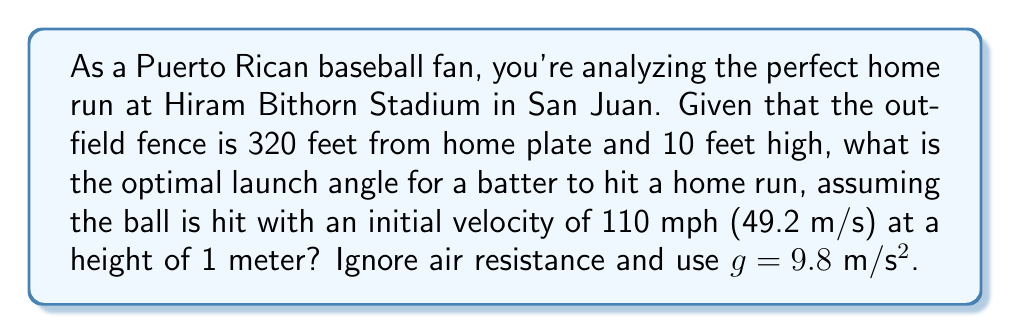Show me your answer to this math problem. Let's approach this step-by-step using projectile motion equations:

1) First, convert all units to meters:
   320 feet ≈ 97.54 m (horizontal distance)
   10 feet ≈ 3.05 m (fence height)
   110 mph = 49.2 m/s (initial velocity)

2) We need to find the angle θ that allows the ball to just clear the fence. The projectile motion equations we'll use are:

   $$x = v_0 \cos(\theta) t$$
   $$y = v_0 \sin(\theta) t - \frac{1}{2}gt^2 + y_0$$

   Where $x$ is horizontal distance, $y$ is vertical distance, $v_0$ is initial velocity, $t$ is time, $g$ is acceleration due to gravity, and $y_0$ is initial height.

3) At the fence, $x = 97.54$ m and $y = 3.05$ m. Solve for $t$ in the first equation:

   $$t = \frac{97.54}{49.2 \cos(\theta)}$$

4) Substitute this into the second equation:

   $$3.05 = 49.2 \sin(\theta) \cdot \frac{97.54}{49.2 \cos(\theta)} - \frac{1}{2} \cdot 9.8 \cdot (\frac{97.54}{49.2 \cos(\theta)})^2 + 1$$

5) Simplify:

   $$3.05 = 97.54 \tan(\theta) - 4.9 \cdot \frac{97.54^2}{2422.64 \cos^2(\theta)} + 1$$

6) This equation can be solved numerically. Using a computer algebra system or numerical methods, we find that θ ≈ 27.7°.

7) To verify this is the optimal angle, we can check angles slightly above and below this value. We find that they either result in the ball not reaching the fence or going unnecessarily high.
Answer: 27.7° 